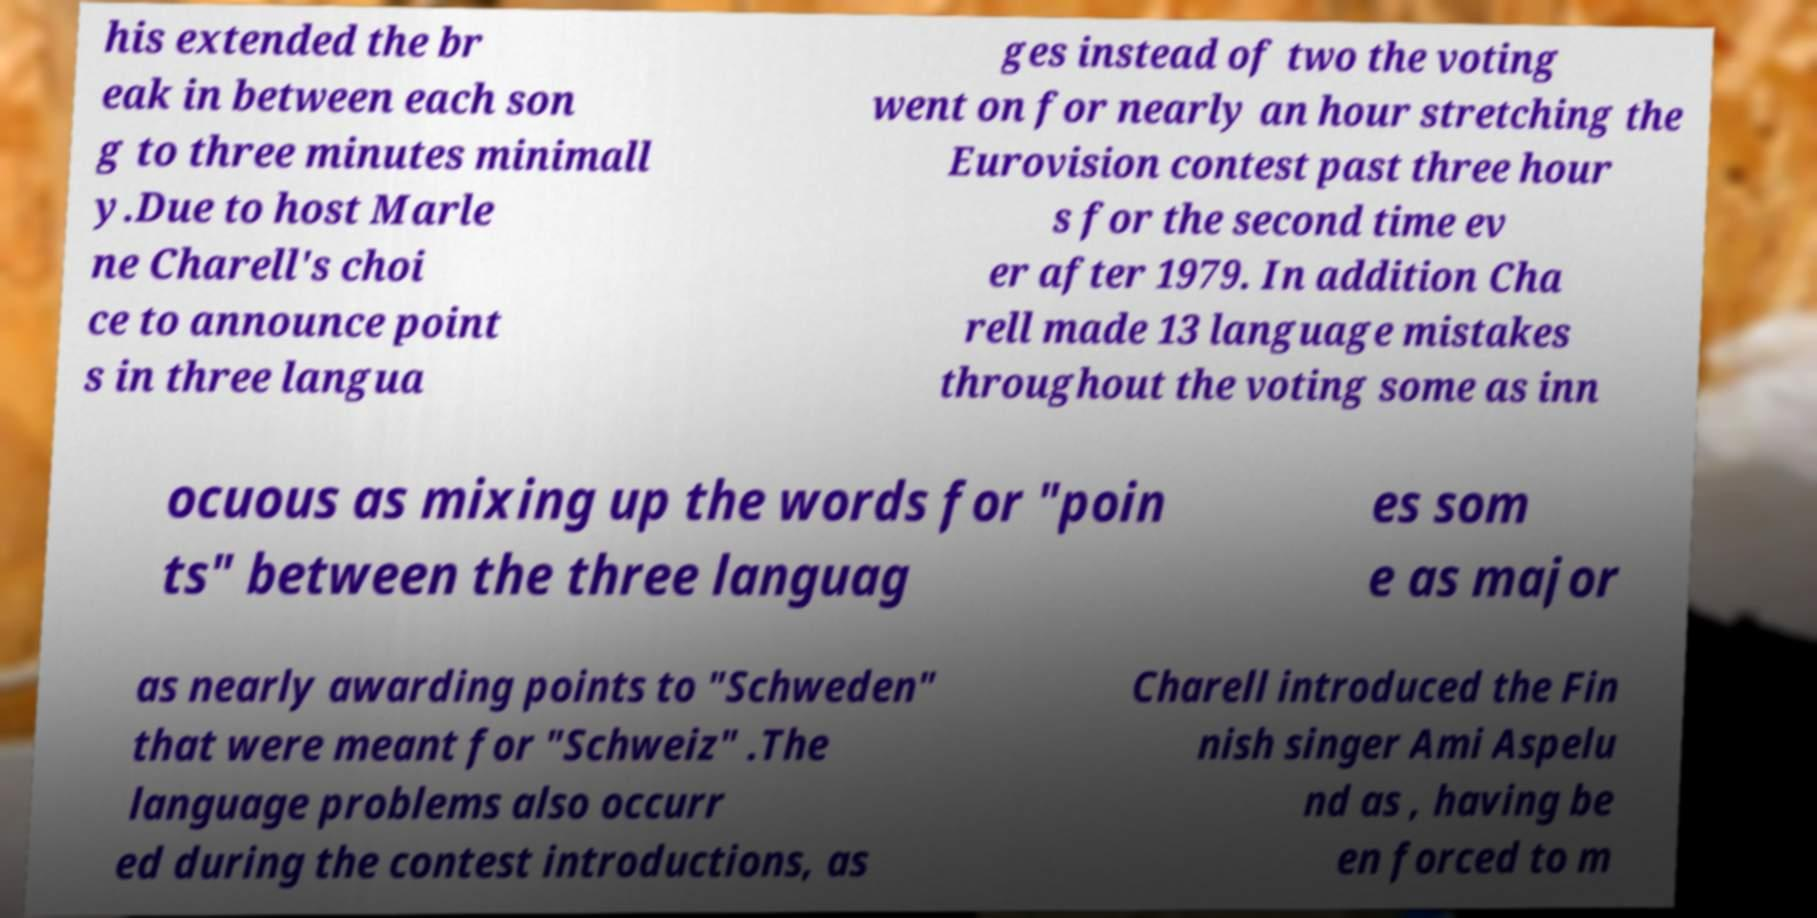What messages or text are displayed in this image? I need them in a readable, typed format. his extended the br eak in between each son g to three minutes minimall y.Due to host Marle ne Charell's choi ce to announce point s in three langua ges instead of two the voting went on for nearly an hour stretching the Eurovision contest past three hour s for the second time ev er after 1979. In addition Cha rell made 13 language mistakes throughout the voting some as inn ocuous as mixing up the words for "poin ts" between the three languag es som e as major as nearly awarding points to "Schweden" that were meant for "Schweiz" .The language problems also occurr ed during the contest introductions, as Charell introduced the Fin nish singer Ami Aspelu nd as , having be en forced to m 